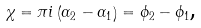<formula> <loc_0><loc_0><loc_500><loc_500>\chi = \pi i \left ( \alpha _ { 2 } - \alpha _ { 1 } \right ) = \phi _ { 2 } - \phi _ { 1 } \text {,}</formula> 